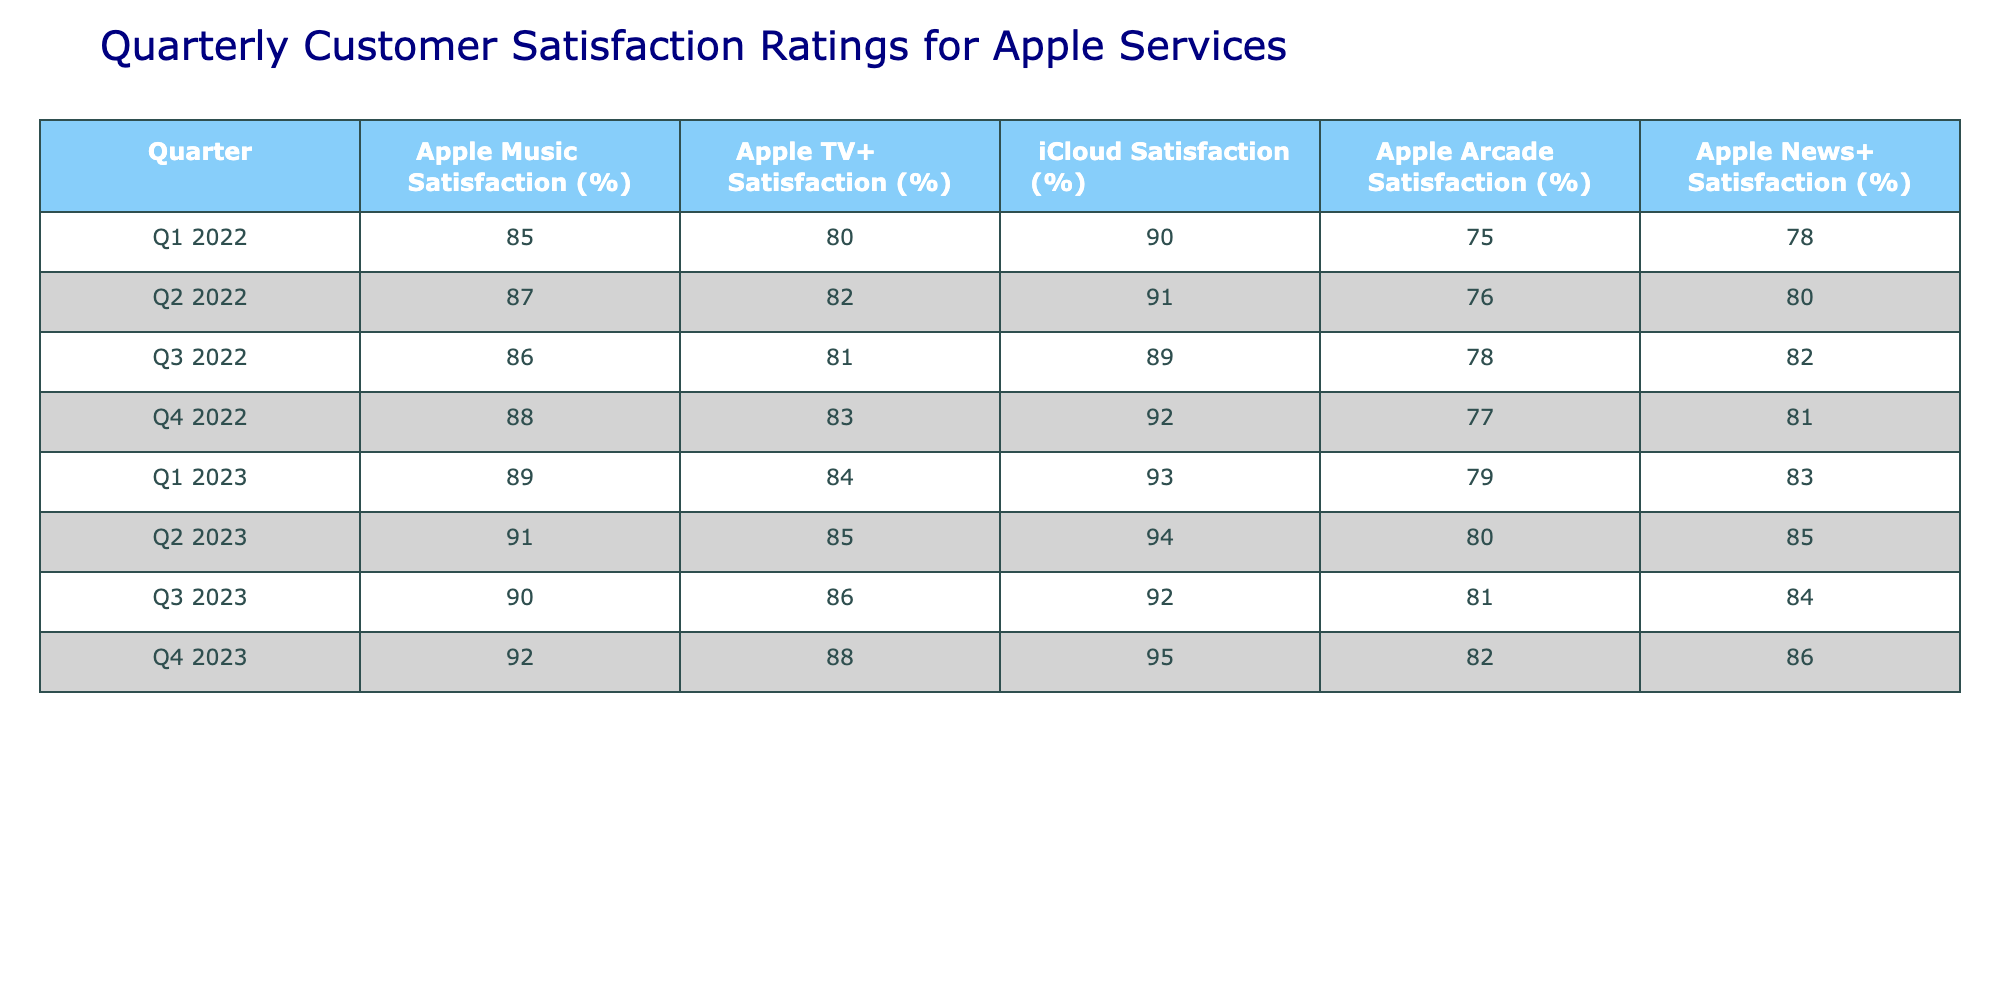What was the satisfaction percentage for Apple Music in Q4 2023? The table shows the value for Apple Music satisfaction in Q4 2023 directly listed under that column. The value is 92%.
Answer: 92% Which Apple service had the highest satisfaction rating in Q1 2022? By examining the ratings in Q1 2022 across the services, iCloud satisfaction is the highest at 90%, compared to the others.
Answer: iCloud Satisfaction What is the average satisfaction rating for Apple TV+ from Q1 2022 to Q4 2023? To find the average, first sum the satisfaction ratings for Apple TV+ over the specified quarters: (80 + 82 + 81 + 83 + 84 + 85 + 86 + 88) = 668. Then divide by the number of quarters, which is 8: 668 / 8 = 83.5.
Answer: 83.5 Did Apple Arcade satisfaction increase every quarter from Q1 2022 to Q4 2023? To confirm this, we look at the Apple Arcade satisfaction ratings for each quarter: 75, 76, 78, 77, 79, 80, 81, 82. The data shows a fluctuation, with some increases and decreases. Therefore, the answer is no.
Answer: No What was the difference in satisfaction ratings for iCloud between Q1 2022 and Q2 2023? The rating for iCloud in Q1 2022 is 90% and for Q2 2023 is 94%. To find the difference, you subtract these two values: 94 - 90 = 4.
Answer: 4 What was the trend in customer satisfaction for Apple News+ from Q1 2022 to Q4 2023? Analyzing the satisfaction values for Apple News+ shows a progression: 78, 80, 82, 81, 83, 85, 84, 86. The values generally show an upward trend except for a slight decrease from Q3 2023 to Q4 2023. Therefore, the overall trend can be described as increasing.
Answer: Increasing What service had the lowest satisfaction rating in Q3 2022? The table lists Apple's service satisfaction ratings for Q3 2022, where Apple Arcade shows the lowest rating at 78%, compared to other services listed for that quarter.
Answer: Apple Arcade Which quarter had the highest overall satisfaction across all five Apple services? To determine the highest overall satisfaction, we sum the satisfaction ratings for each quarter: Q1 2022: 85+80+90+75+78=408, Q2 2022: 87+82+91+76+80=416, Q3 2022: 86+81+89+78+82=416, Q4 2022: 88+83+92+77+81=421, Q1 2023: 89+84+93+79+83=428, Q2 2023: 91+85+94+80+85=435, Q3 2023: 90+86+92+81+84=433, Q4 2023: 92+88+95+82+86=443. The highest sum is from Q4 2023 with 443.
Answer: Q4 2023 